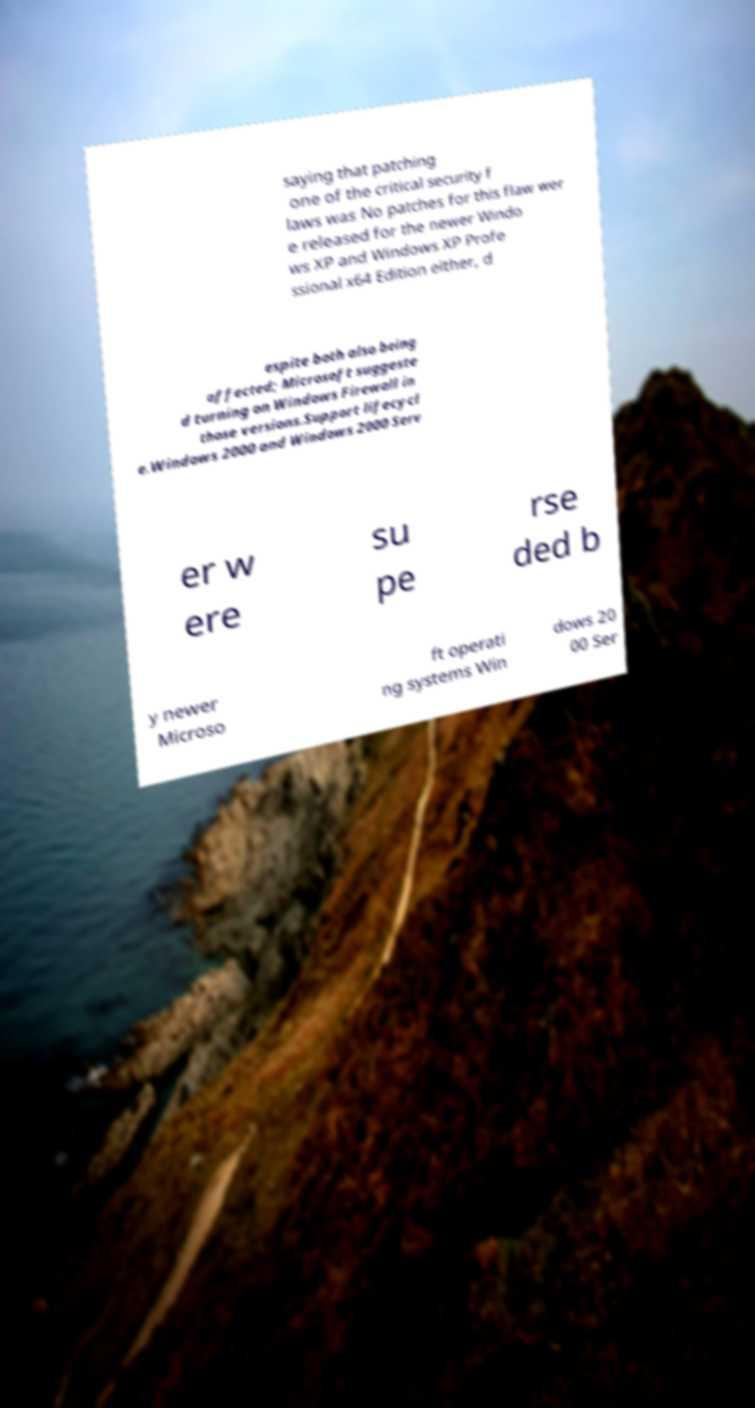Please identify and transcribe the text found in this image. saying that patching one of the critical security f laws was No patches for this flaw wer e released for the newer Windo ws XP and Windows XP Profe ssional x64 Edition either, d espite both also being affected; Microsoft suggeste d turning on Windows Firewall in those versions.Support lifecycl e.Windows 2000 and Windows 2000 Serv er w ere su pe rse ded b y newer Microso ft operati ng systems Win dows 20 00 Ser 